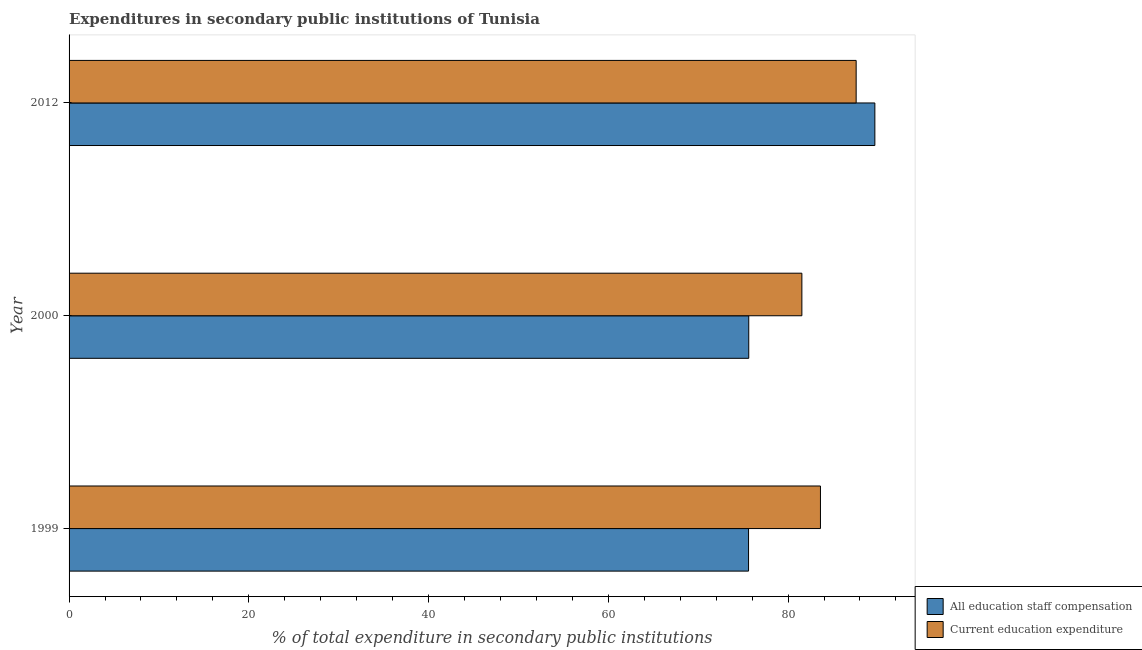Are the number of bars per tick equal to the number of legend labels?
Keep it short and to the point. Yes. Are the number of bars on each tick of the Y-axis equal?
Make the answer very short. Yes. How many bars are there on the 2nd tick from the top?
Provide a succinct answer. 2. How many bars are there on the 1st tick from the bottom?
Offer a terse response. 2. What is the label of the 2nd group of bars from the top?
Provide a short and direct response. 2000. What is the expenditure in education in 2000?
Ensure brevity in your answer.  81.53. Across all years, what is the maximum expenditure in staff compensation?
Provide a succinct answer. 89.65. Across all years, what is the minimum expenditure in staff compensation?
Keep it short and to the point. 75.6. In which year was the expenditure in staff compensation maximum?
Provide a succinct answer. 2012. What is the total expenditure in staff compensation in the graph?
Provide a short and direct response. 240.88. What is the difference between the expenditure in education in 1999 and that in 2012?
Provide a succinct answer. -3.97. What is the difference between the expenditure in staff compensation in 1999 and the expenditure in education in 2012?
Make the answer very short. -11.97. What is the average expenditure in education per year?
Your response must be concise. 84.24. In the year 2000, what is the difference between the expenditure in education and expenditure in staff compensation?
Your response must be concise. 5.91. In how many years, is the expenditure in staff compensation greater than 32 %?
Provide a succinct answer. 3. What is the ratio of the expenditure in education in 1999 to that in 2012?
Make the answer very short. 0.95. What is the difference between the highest and the second highest expenditure in education?
Make the answer very short. 3.97. What is the difference between the highest and the lowest expenditure in staff compensation?
Give a very brief answer. 14.05. Is the sum of the expenditure in staff compensation in 1999 and 2000 greater than the maximum expenditure in education across all years?
Provide a short and direct response. Yes. What does the 1st bar from the top in 2012 represents?
Offer a terse response. Current education expenditure. What does the 2nd bar from the bottom in 2000 represents?
Make the answer very short. Current education expenditure. How many bars are there?
Your answer should be very brief. 6. Are all the bars in the graph horizontal?
Give a very brief answer. Yes. What is the difference between two consecutive major ticks on the X-axis?
Give a very brief answer. 20. How many legend labels are there?
Your answer should be very brief. 2. What is the title of the graph?
Make the answer very short. Expenditures in secondary public institutions of Tunisia. Does "US$" appear as one of the legend labels in the graph?
Provide a succinct answer. No. What is the label or title of the X-axis?
Ensure brevity in your answer.  % of total expenditure in secondary public institutions. What is the % of total expenditure in secondary public institutions of All education staff compensation in 1999?
Provide a succinct answer. 75.6. What is the % of total expenditure in secondary public institutions of Current education expenditure in 1999?
Offer a very short reply. 83.6. What is the % of total expenditure in secondary public institutions in All education staff compensation in 2000?
Give a very brief answer. 75.62. What is the % of total expenditure in secondary public institutions of Current education expenditure in 2000?
Offer a terse response. 81.53. What is the % of total expenditure in secondary public institutions in All education staff compensation in 2012?
Your response must be concise. 89.65. What is the % of total expenditure in secondary public institutions of Current education expenditure in 2012?
Your answer should be very brief. 87.57. Across all years, what is the maximum % of total expenditure in secondary public institutions of All education staff compensation?
Your answer should be very brief. 89.65. Across all years, what is the maximum % of total expenditure in secondary public institutions of Current education expenditure?
Provide a succinct answer. 87.57. Across all years, what is the minimum % of total expenditure in secondary public institutions in All education staff compensation?
Provide a short and direct response. 75.6. Across all years, what is the minimum % of total expenditure in secondary public institutions of Current education expenditure?
Offer a very short reply. 81.53. What is the total % of total expenditure in secondary public institutions of All education staff compensation in the graph?
Ensure brevity in your answer.  240.88. What is the total % of total expenditure in secondary public institutions in Current education expenditure in the graph?
Ensure brevity in your answer.  252.71. What is the difference between the % of total expenditure in secondary public institutions in All education staff compensation in 1999 and that in 2000?
Your response must be concise. -0.02. What is the difference between the % of total expenditure in secondary public institutions in Current education expenditure in 1999 and that in 2000?
Give a very brief answer. 2.07. What is the difference between the % of total expenditure in secondary public institutions of All education staff compensation in 1999 and that in 2012?
Make the answer very short. -14.05. What is the difference between the % of total expenditure in secondary public institutions of Current education expenditure in 1999 and that in 2012?
Your answer should be compact. -3.97. What is the difference between the % of total expenditure in secondary public institutions in All education staff compensation in 2000 and that in 2012?
Your answer should be very brief. -14.03. What is the difference between the % of total expenditure in secondary public institutions in Current education expenditure in 2000 and that in 2012?
Give a very brief answer. -6.04. What is the difference between the % of total expenditure in secondary public institutions of All education staff compensation in 1999 and the % of total expenditure in secondary public institutions of Current education expenditure in 2000?
Your response must be concise. -5.93. What is the difference between the % of total expenditure in secondary public institutions of All education staff compensation in 1999 and the % of total expenditure in secondary public institutions of Current education expenditure in 2012?
Provide a succinct answer. -11.97. What is the difference between the % of total expenditure in secondary public institutions in All education staff compensation in 2000 and the % of total expenditure in secondary public institutions in Current education expenditure in 2012?
Your answer should be very brief. -11.95. What is the average % of total expenditure in secondary public institutions in All education staff compensation per year?
Your answer should be compact. 80.29. What is the average % of total expenditure in secondary public institutions in Current education expenditure per year?
Your response must be concise. 84.24. In the year 2000, what is the difference between the % of total expenditure in secondary public institutions of All education staff compensation and % of total expenditure in secondary public institutions of Current education expenditure?
Keep it short and to the point. -5.91. In the year 2012, what is the difference between the % of total expenditure in secondary public institutions in All education staff compensation and % of total expenditure in secondary public institutions in Current education expenditure?
Your response must be concise. 2.08. What is the ratio of the % of total expenditure in secondary public institutions of Current education expenditure in 1999 to that in 2000?
Your response must be concise. 1.03. What is the ratio of the % of total expenditure in secondary public institutions in All education staff compensation in 1999 to that in 2012?
Provide a short and direct response. 0.84. What is the ratio of the % of total expenditure in secondary public institutions in Current education expenditure in 1999 to that in 2012?
Ensure brevity in your answer.  0.95. What is the ratio of the % of total expenditure in secondary public institutions of All education staff compensation in 2000 to that in 2012?
Make the answer very short. 0.84. What is the difference between the highest and the second highest % of total expenditure in secondary public institutions in All education staff compensation?
Make the answer very short. 14.03. What is the difference between the highest and the second highest % of total expenditure in secondary public institutions in Current education expenditure?
Make the answer very short. 3.97. What is the difference between the highest and the lowest % of total expenditure in secondary public institutions of All education staff compensation?
Offer a very short reply. 14.05. What is the difference between the highest and the lowest % of total expenditure in secondary public institutions in Current education expenditure?
Offer a very short reply. 6.04. 